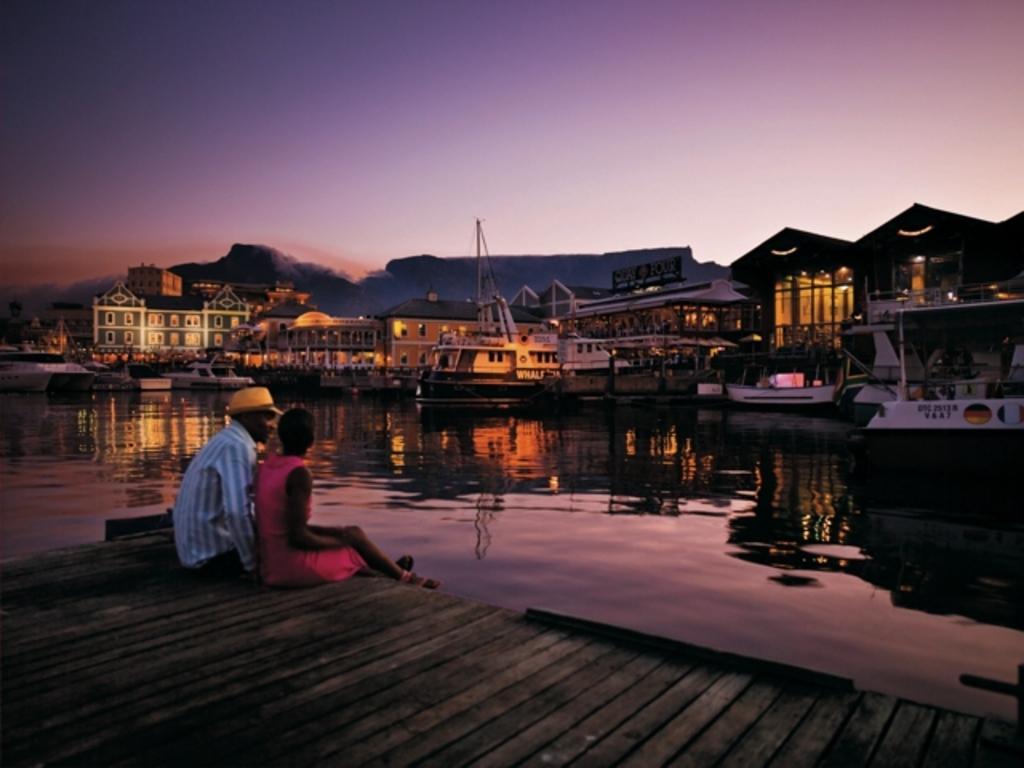Please provide a concise description of this image. In this image, we can see people sitting on the broad bridge and one of them is wearing a cap. In the background, there are boats, buildings, lights, ships and boards and there are hills. At the top, there is sky and at the bottom, there is water. 